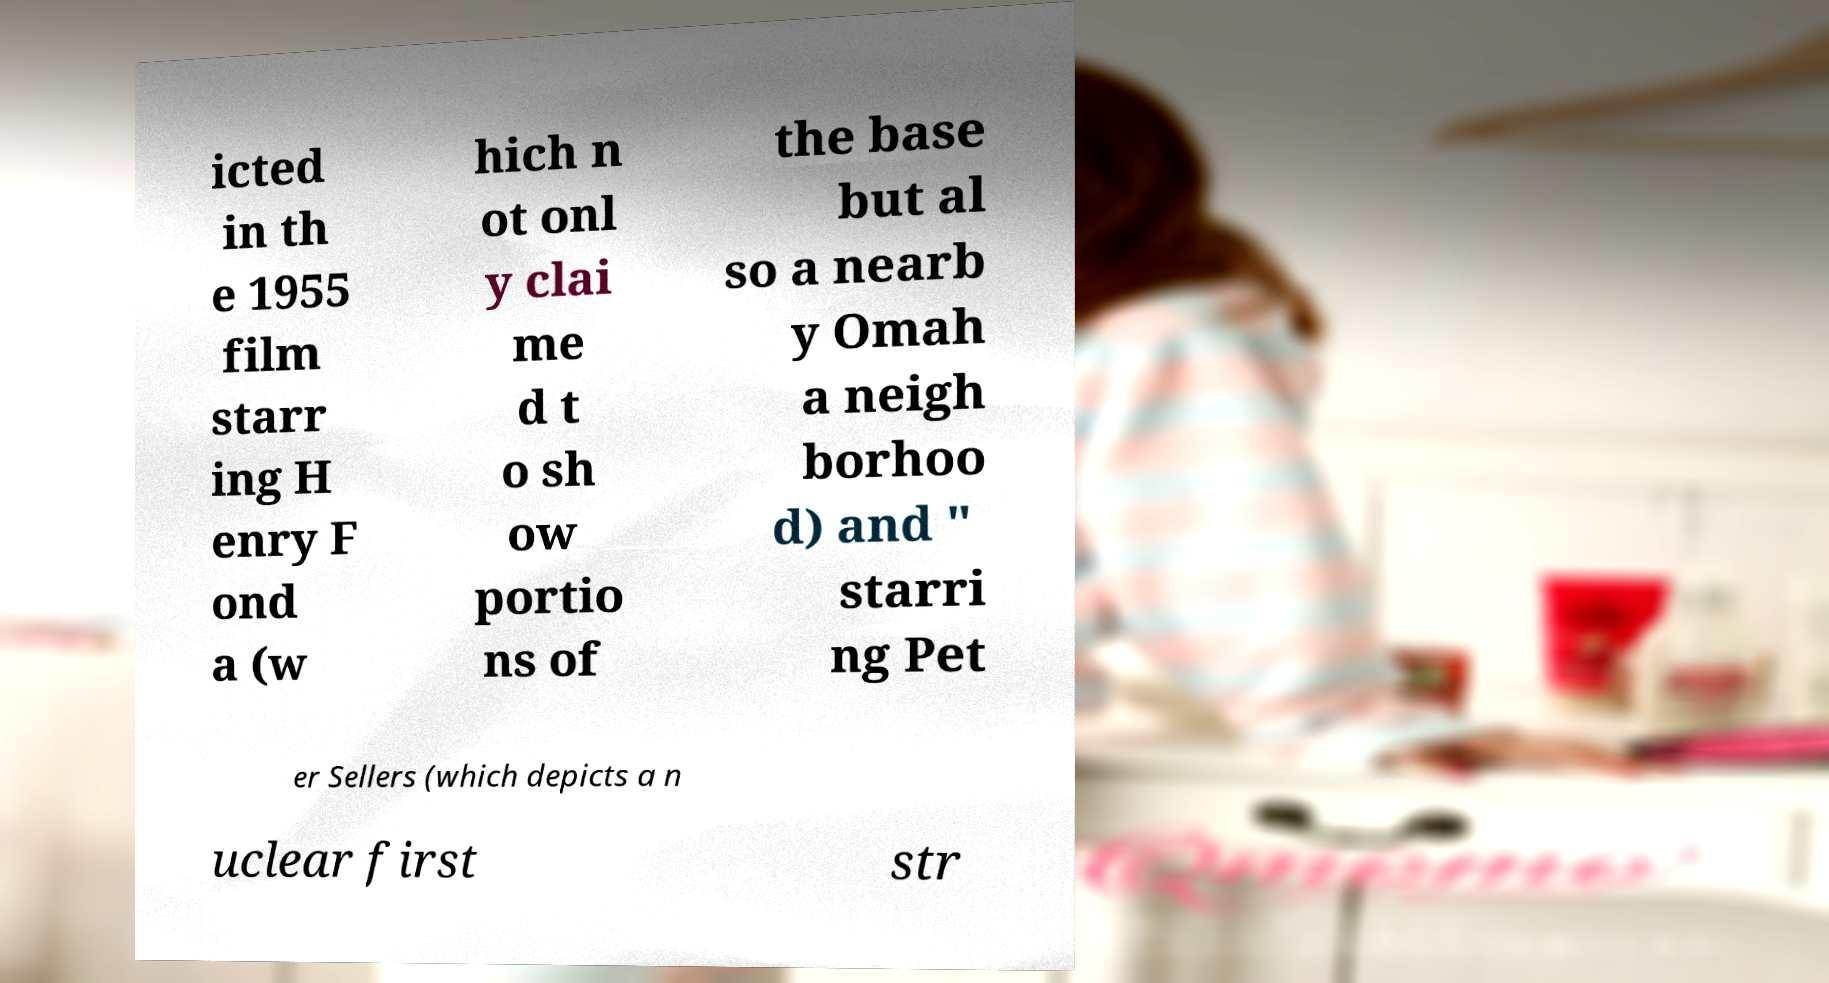I need the written content from this picture converted into text. Can you do that? icted in th e 1955 film starr ing H enry F ond a (w hich n ot onl y clai me d t o sh ow portio ns of the base but al so a nearb y Omah a neigh borhoo d) and " starri ng Pet er Sellers (which depicts a n uclear first str 